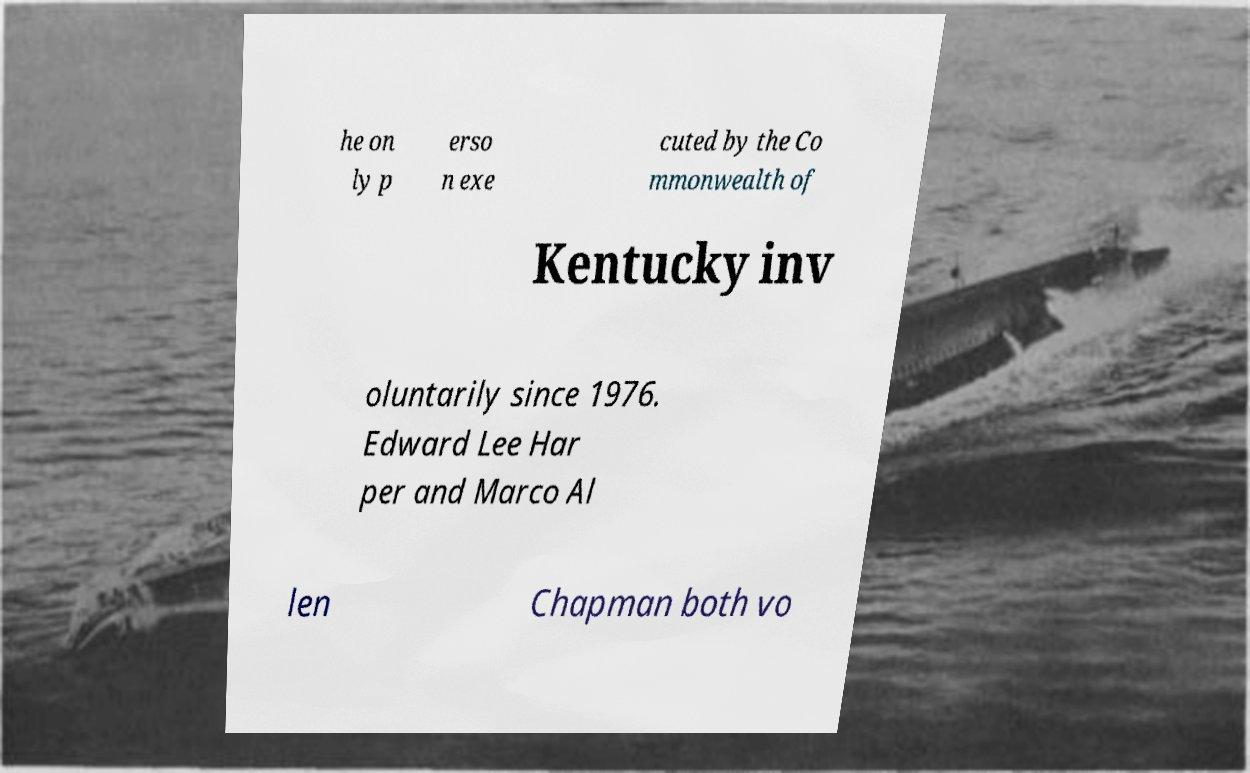Could you assist in decoding the text presented in this image and type it out clearly? he on ly p erso n exe cuted by the Co mmonwealth of Kentucky inv oluntarily since 1976. Edward Lee Har per and Marco Al len Chapman both vo 